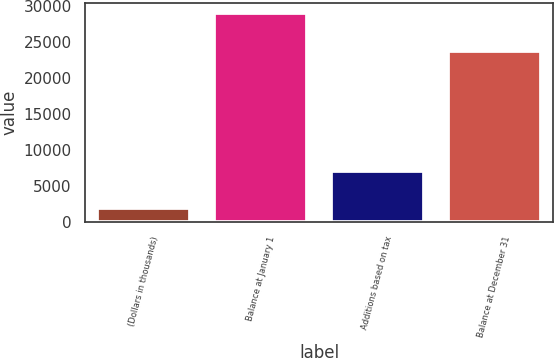Convert chart. <chart><loc_0><loc_0><loc_500><loc_500><bar_chart><fcel>(Dollars in thousands)<fcel>Balance at January 1<fcel>Additions based on tax<fcel>Balance at December 31<nl><fcel>2010<fcel>29010<fcel>7119<fcel>23773<nl></chart> 